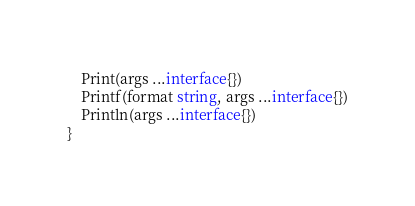Convert code to text. <code><loc_0><loc_0><loc_500><loc_500><_Go_>	Print(args ...interface{})
	Printf(format string, args ...interface{})
	Println(args ...interface{})
}
</code> 